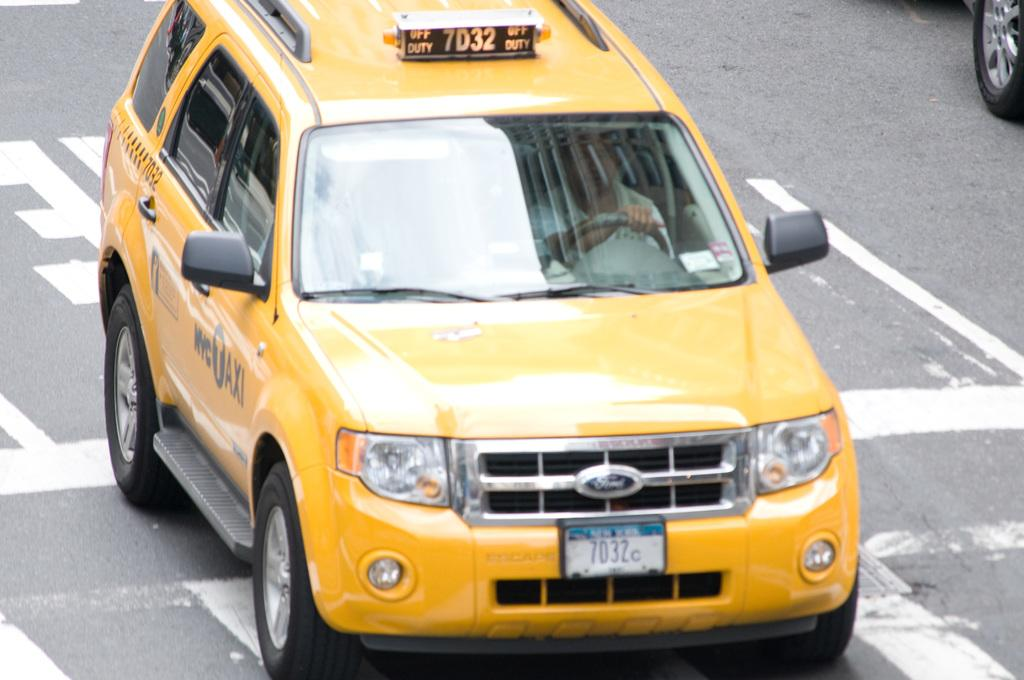Provide a one-sentence caption for the provided image. New York taxi number 7D32 is off duty. 